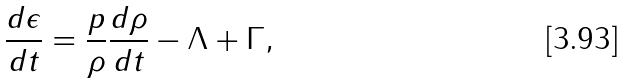<formula> <loc_0><loc_0><loc_500><loc_500>\frac { d \epsilon } { d t } = \frac { p } { \rho } \frac { d \rho } { d t } - \Lambda + \Gamma ,</formula> 